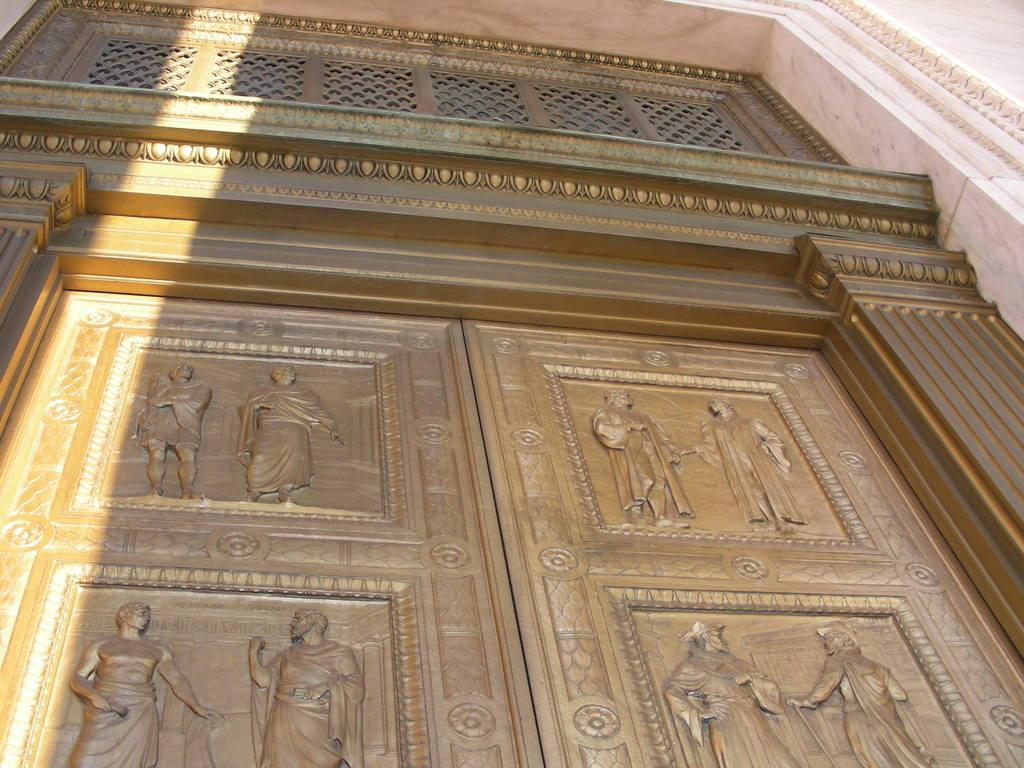Can you describe this image briefly? In this image we can see the sculptures of people on the doors. There is a wall in the image. 